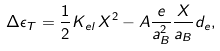<formula> <loc_0><loc_0><loc_500><loc_500>\Delta \epsilon _ { T } = \frac { 1 } { 2 } K _ { e l } \, X ^ { 2 } - A \frac { e } { a _ { B } ^ { 2 } } \frac { X } { a _ { B } } d _ { e } ,</formula> 